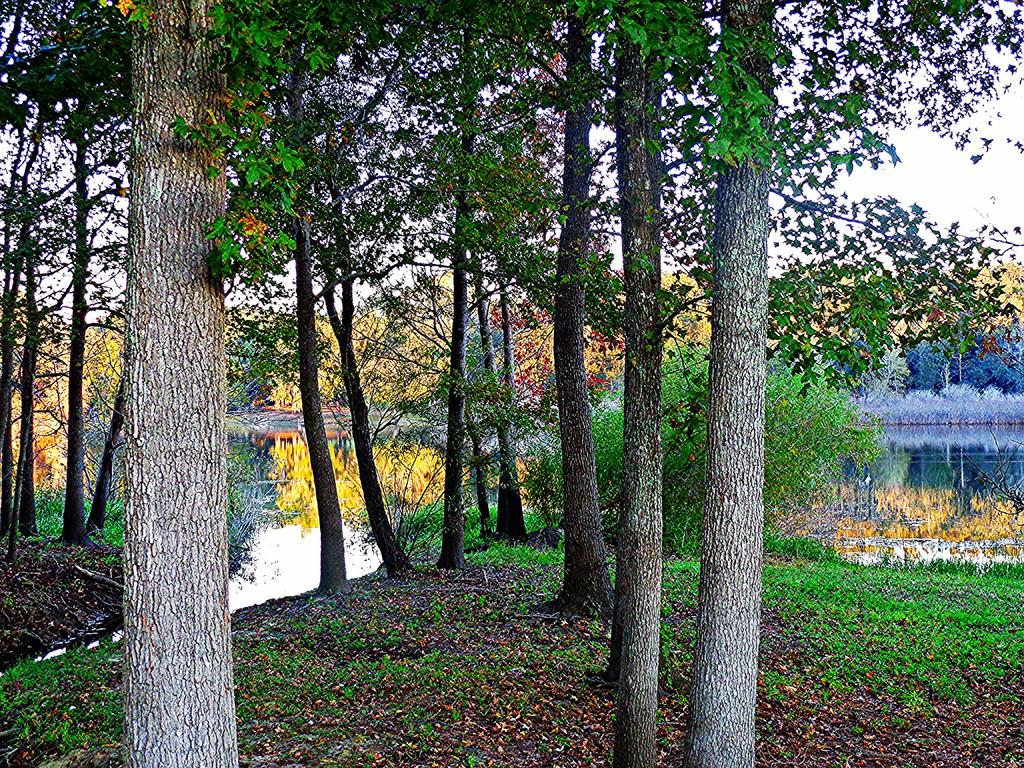What type of vegetation can be seen in the image? There are trees in the image. What is visible behind the trees? The sky is visible behind the trees. What natural element is visible in the image? Water is visible in the image. What celestial bodies can be seen in the image? Planets are visible in the middle of the image. Is the water in the image covering the trees? No, the water is not covering the trees in the image. Can you see any sails in the image? There are no sails present in the image. 